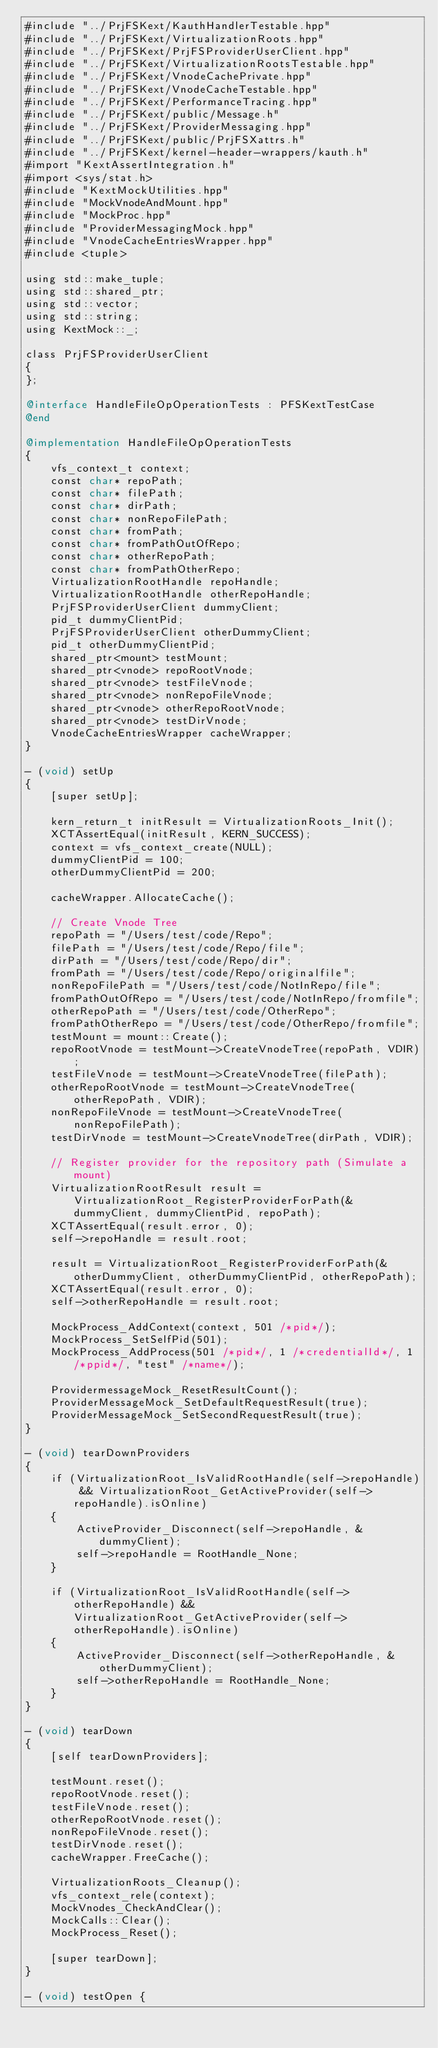<code> <loc_0><loc_0><loc_500><loc_500><_ObjectiveC_>#include "../PrjFSKext/KauthHandlerTestable.hpp"
#include "../PrjFSKext/VirtualizationRoots.hpp"
#include "../PrjFSKext/PrjFSProviderUserClient.hpp"
#include "../PrjFSKext/VirtualizationRootsTestable.hpp"
#include "../PrjFSKext/VnodeCachePrivate.hpp"
#include "../PrjFSKext/VnodeCacheTestable.hpp"
#include "../PrjFSKext/PerformanceTracing.hpp"
#include "../PrjFSKext/public/Message.h"
#include "../PrjFSKext/ProviderMessaging.hpp"
#include "../PrjFSKext/public/PrjFSXattrs.h"
#include "../PrjFSKext/kernel-header-wrappers/kauth.h"
#import "KextAssertIntegration.h"
#import <sys/stat.h>
#include "KextMockUtilities.hpp"
#include "MockVnodeAndMount.hpp"
#include "MockProc.hpp"
#include "ProviderMessagingMock.hpp"
#include "VnodeCacheEntriesWrapper.hpp"
#include <tuple>

using std::make_tuple;
using std::shared_ptr;
using std::vector;
using std::string;
using KextMock::_;

class PrjFSProviderUserClient
{
};

@interface HandleFileOpOperationTests : PFSKextTestCase
@end

@implementation HandleFileOpOperationTests
{
    vfs_context_t context;
    const char* repoPath;
    const char* filePath;
    const char* dirPath;
    const char* nonRepoFilePath;
    const char* fromPath;
    const char* fromPathOutOfRepo;
    const char* otherRepoPath;
    const char* fromPathOtherRepo;
    VirtualizationRootHandle repoHandle;
    VirtualizationRootHandle otherRepoHandle;
    PrjFSProviderUserClient dummyClient;
    pid_t dummyClientPid;
    PrjFSProviderUserClient otherDummyClient;
    pid_t otherDummyClientPid;
    shared_ptr<mount> testMount;
    shared_ptr<vnode> repoRootVnode;
    shared_ptr<vnode> testFileVnode;
    shared_ptr<vnode> nonRepoFileVnode;
    shared_ptr<vnode> otherRepoRootVnode;
    shared_ptr<vnode> testDirVnode;
    VnodeCacheEntriesWrapper cacheWrapper;
}

- (void) setUp
{
    [super setUp];

    kern_return_t initResult = VirtualizationRoots_Init();
    XCTAssertEqual(initResult, KERN_SUCCESS);
    context = vfs_context_create(NULL);
    dummyClientPid = 100;
    otherDummyClientPid = 200;

    cacheWrapper.AllocateCache();

    // Create Vnode Tree
    repoPath = "/Users/test/code/Repo";
    filePath = "/Users/test/code/Repo/file";
    dirPath = "/Users/test/code/Repo/dir";
    fromPath = "/Users/test/code/Repo/originalfile";
    nonRepoFilePath = "/Users/test/code/NotInRepo/file";
    fromPathOutOfRepo = "/Users/test/code/NotInRepo/fromfile";
    otherRepoPath = "/Users/test/code/OtherRepo";
    fromPathOtherRepo = "/Users/test/code/OtherRepo/fromfile";
    testMount = mount::Create();
    repoRootVnode = testMount->CreateVnodeTree(repoPath, VDIR);
    testFileVnode = testMount->CreateVnodeTree(filePath);
    otherRepoRootVnode = testMount->CreateVnodeTree(otherRepoPath, VDIR);
    nonRepoFileVnode = testMount->CreateVnodeTree(nonRepoFilePath);
    testDirVnode = testMount->CreateVnodeTree(dirPath, VDIR);

    // Register provider for the repository path (Simulate a mount)
    VirtualizationRootResult result = VirtualizationRoot_RegisterProviderForPath(&dummyClient, dummyClientPid, repoPath);
    XCTAssertEqual(result.error, 0);
    self->repoHandle = result.root;
    
    result = VirtualizationRoot_RegisterProviderForPath(&otherDummyClient, otherDummyClientPid, otherRepoPath);
    XCTAssertEqual(result.error, 0);
    self->otherRepoHandle = result.root;

    MockProcess_AddContext(context, 501 /*pid*/);
    MockProcess_SetSelfPid(501);
    MockProcess_AddProcess(501 /*pid*/, 1 /*credentialId*/, 1 /*ppid*/, "test" /*name*/);
    
    ProvidermessageMock_ResetResultCount();
    ProviderMessageMock_SetDefaultRequestResult(true);
    ProviderMessageMock_SetSecondRequestResult(true);
}

- (void) tearDownProviders
{
    if (VirtualizationRoot_IsValidRootHandle(self->repoHandle) && VirtualizationRoot_GetActiveProvider(self->repoHandle).isOnline)
    {
        ActiveProvider_Disconnect(self->repoHandle, &dummyClient);
        self->repoHandle = RootHandle_None;
    }

    if (VirtualizationRoot_IsValidRootHandle(self->otherRepoHandle) && VirtualizationRoot_GetActiveProvider(self->otherRepoHandle).isOnline)
    {
        ActiveProvider_Disconnect(self->otherRepoHandle, &otherDummyClient);
        self->otherRepoHandle = RootHandle_None;
    }
}

- (void) tearDown
{
    [self tearDownProviders];
    
    testMount.reset();
    repoRootVnode.reset();
    testFileVnode.reset();
    otherRepoRootVnode.reset();
    nonRepoFileVnode.reset();
    testDirVnode.reset();
    cacheWrapper.FreeCache();
    
    VirtualizationRoots_Cleanup();
    vfs_context_rele(context);
    MockVnodes_CheckAndClear();
    MockCalls::Clear();
    MockProcess_Reset();

    [super tearDown];
}

- (void) testOpen {</code> 